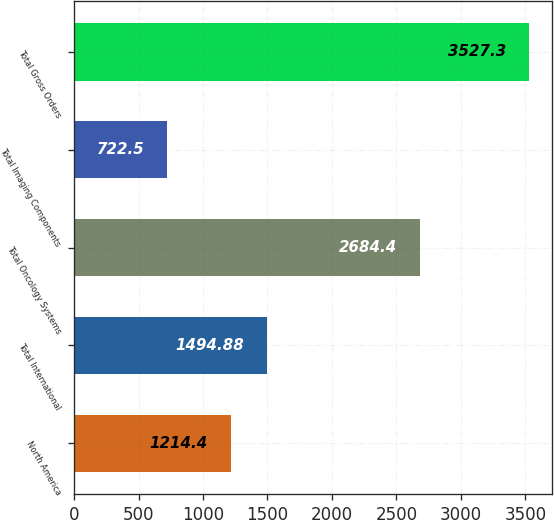<chart> <loc_0><loc_0><loc_500><loc_500><bar_chart><fcel>North America<fcel>Total International<fcel>Total Oncology Systems<fcel>Total Imaging Components<fcel>Total Gross Orders<nl><fcel>1214.4<fcel>1494.88<fcel>2684.4<fcel>722.5<fcel>3527.3<nl></chart> 